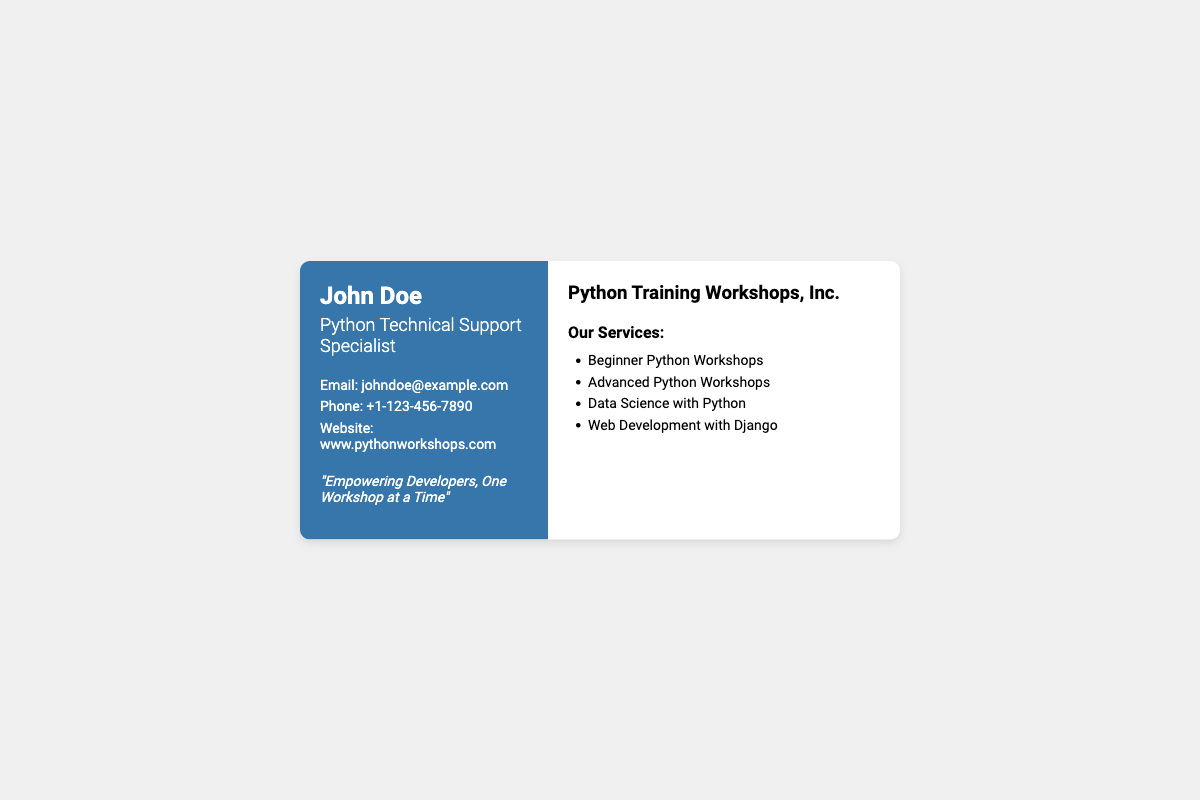What is the name on the business card? The name displayed prominently on the business card is "John Doe."
Answer: John Doe What is the title of the person? The title listed on the business card describes the person's expertise as "Python Technical Support Specialist."
Answer: Python Technical Support Specialist What is the phone number provided? The contact information includes a phone number for reaching John Doe: "+1-123-456-7890."
Answer: +1-123-456-7890 What type of workshops are offered? The document lists several types of workshops, including "Beginner Python Workshops."
Answer: Beginner Python Workshops How many types of workshops are mentioned? The document outlines four specific types of workshops in the services section, indicating variety in offerings.
Answer: 4 What is the tagline on the business card? The business card includes a catchy tagline: "Empowering Developers, One Workshop at a Time."
Answer: Empowering Developers, One Workshop at a Time What is the website address provided? The business card provides a website for further information, which is "www.pythonworkshops.com."
Answer: www.pythonworkshops.com What is the background color of the left panel? The left panel of the business card features a specific color, which is "blue."
Answer: blue 